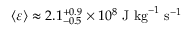Convert formula to latex. <formula><loc_0><loc_0><loc_500><loc_500>\left \langle \varepsilon \right \rangle \approx 2 . 1 _ { - 0 . 5 } ^ { + 0 . 9 } \times 1 0 ^ { 8 } J k g ^ { - 1 } s ^ { - 1 }</formula> 